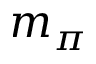Convert formula to latex. <formula><loc_0><loc_0><loc_500><loc_500>m _ { \pi }</formula> 